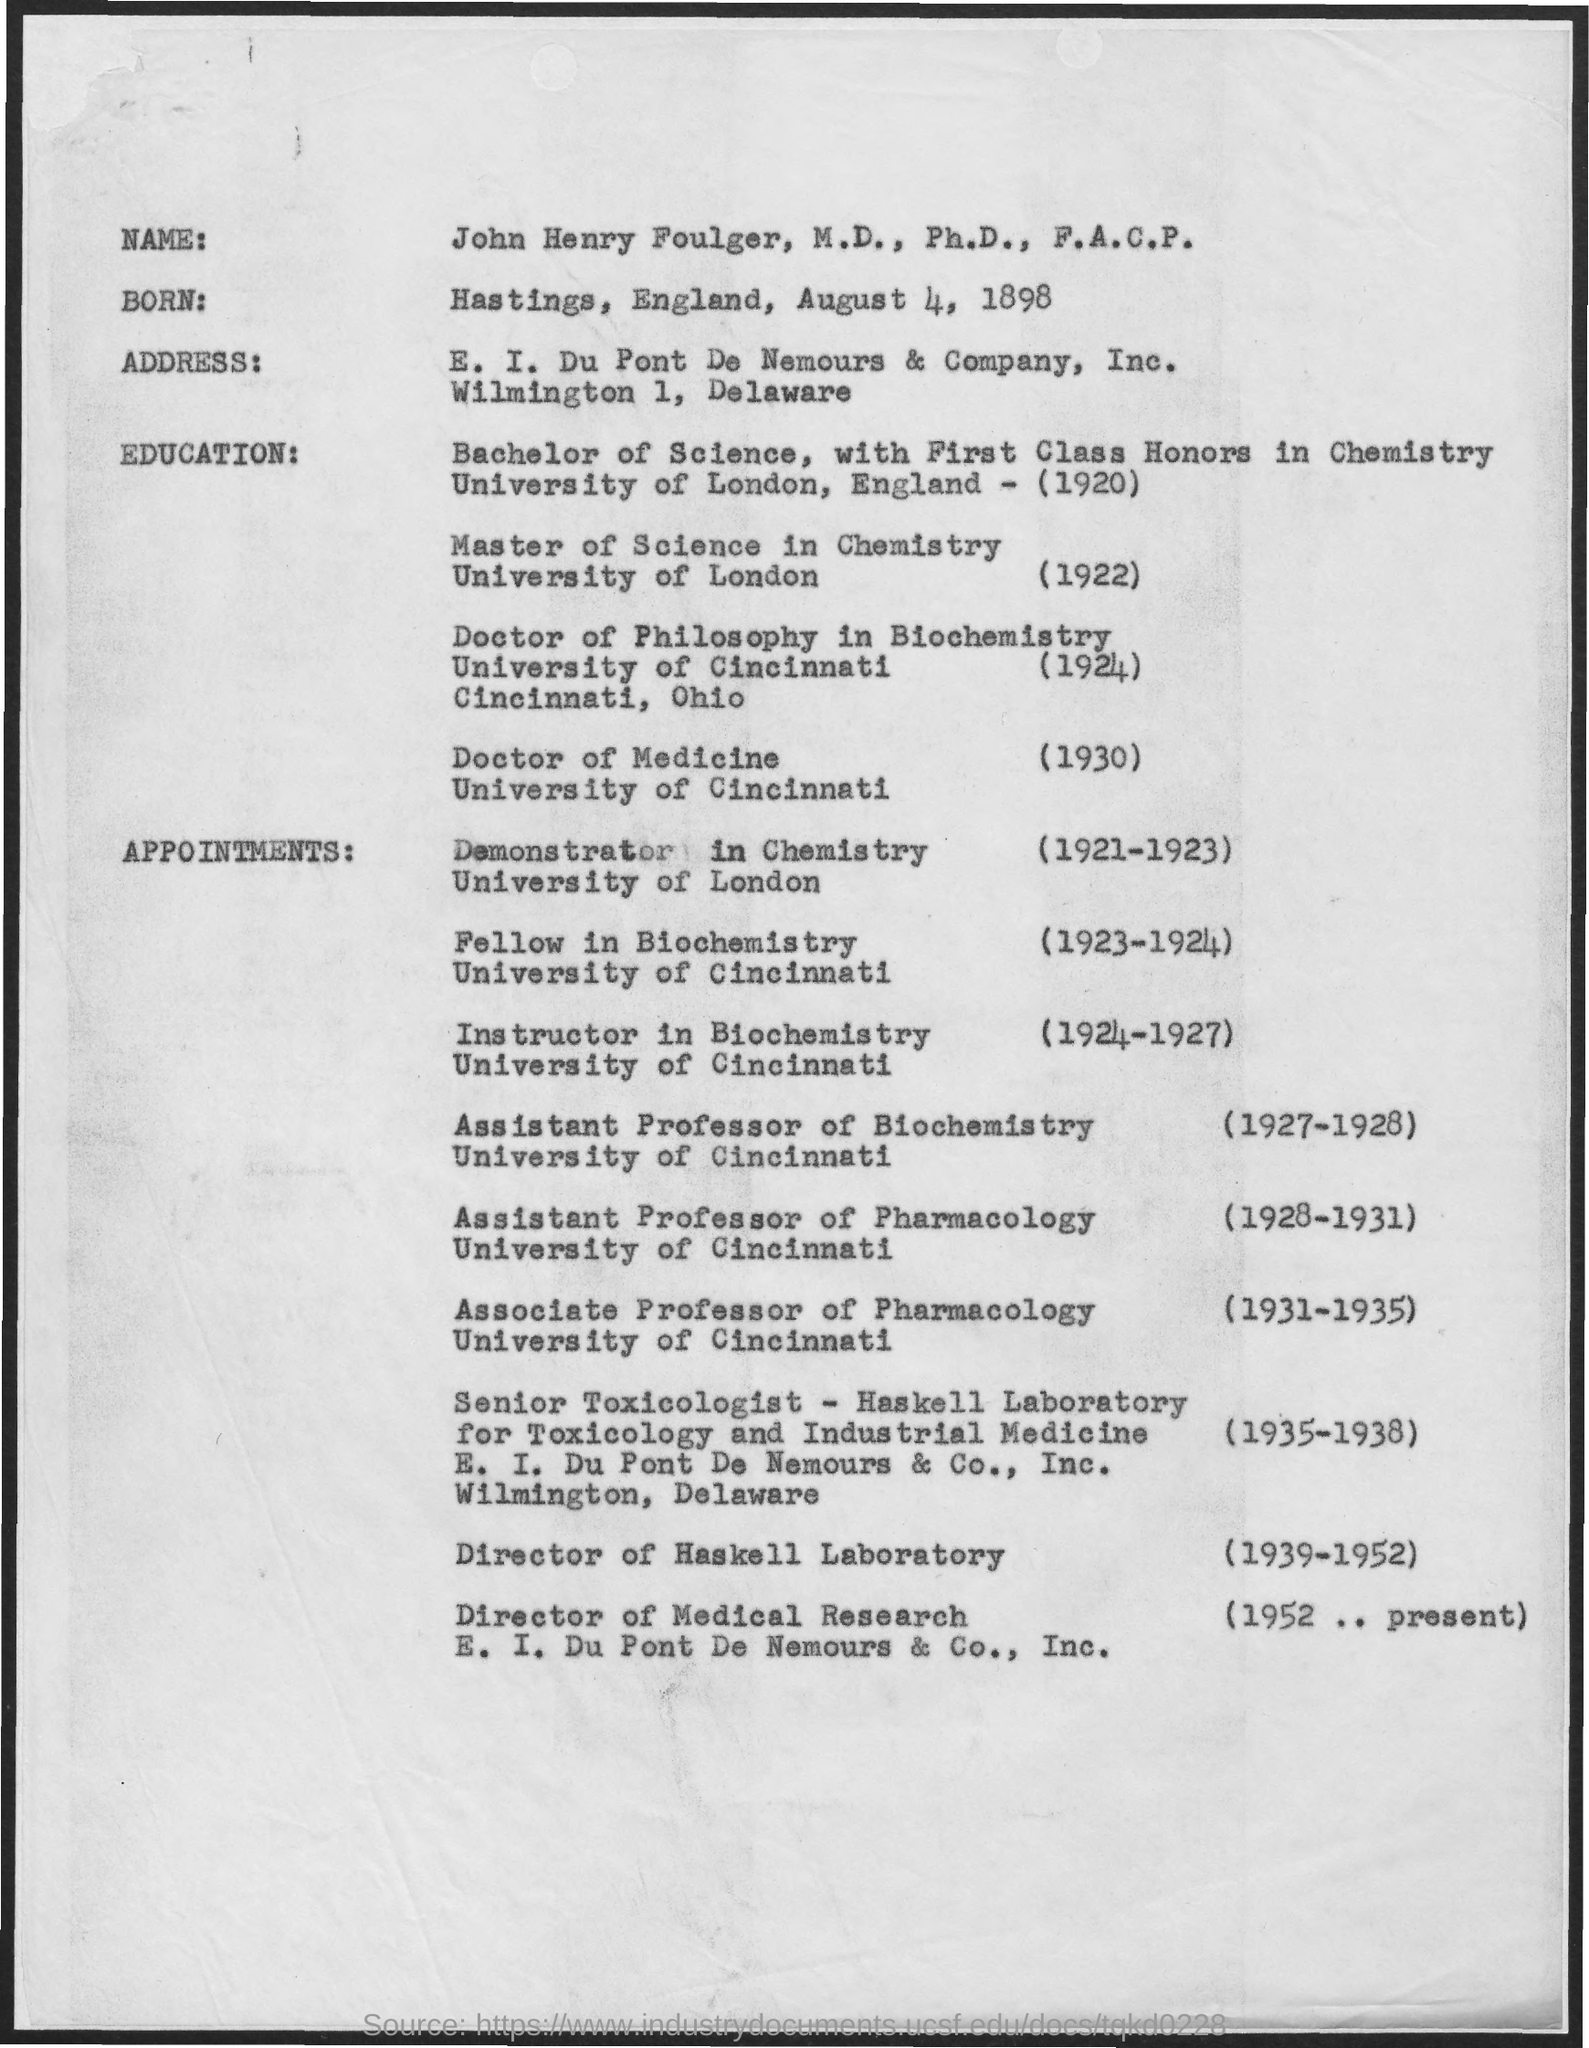Mention a couple of crucial points in this snapshot. John Henry Foulger, M.D., Ph.D., F.A.C.P, completed his bachelor's degree from the University of London in England. John Henry Foulger, M.D., Ph.D.,F.A.C.P, completed his Doctor of Medicine in 1930. John Henry Foulger, M.D., Ph.D., F.A.C.P, completed his Doctor of Medicine degree from the University of Cincinnati. John Henry Foulger, M.D., Ph.D., F.A.C.P, completed his bachelor's degree in 1920. 